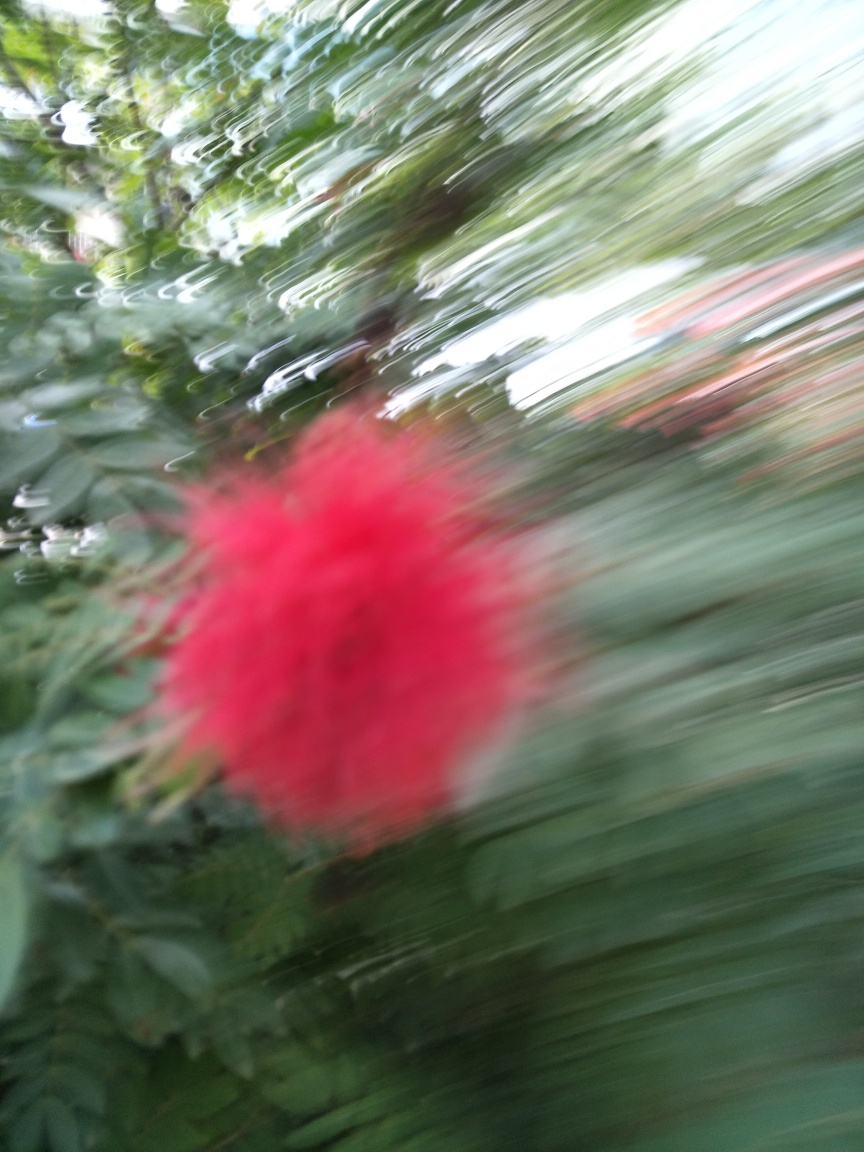Could this image be used artistically despite the blur? Absolutely, the blurred effect gives the image an abstract quality that can evoke a sense of movement and energy, which may be desirable in certain artistic contexts. How might one describe the colors in this image? The colors in the image are quite vibrant, with the red of the flower standing out amidst varying shades of green from the foliage. The blur creates a painterly effect with the colors softly blending into one another. 